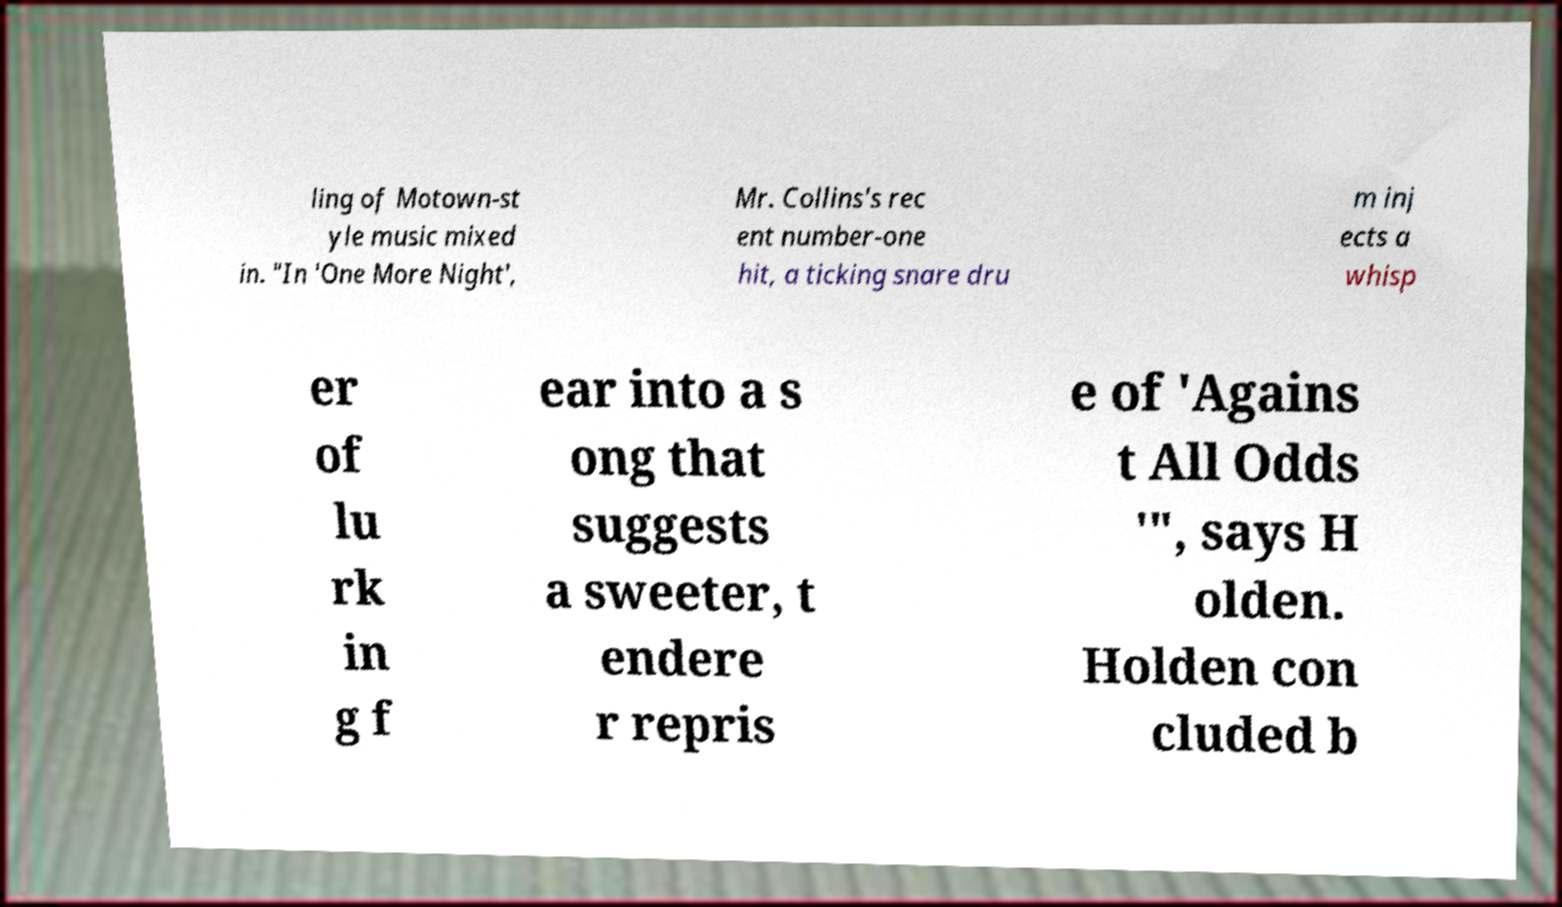Please read and relay the text visible in this image. What does it say? ling of Motown-st yle music mixed in. "In 'One More Night', Mr. Collins's rec ent number-one hit, a ticking snare dru m inj ects a whisp er of lu rk in g f ear into a s ong that suggests a sweeter, t endere r repris e of 'Agains t All Odds '", says H olden. Holden con cluded b 